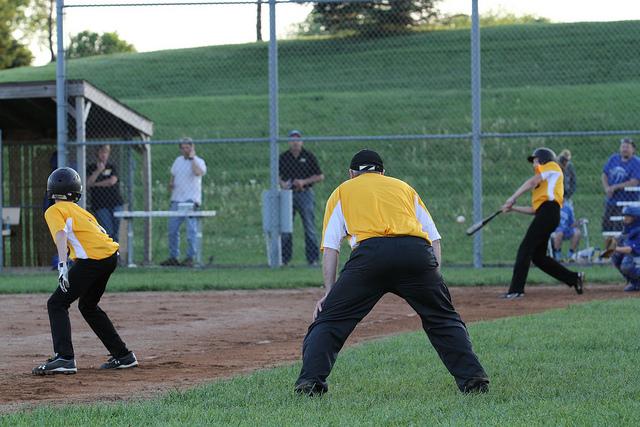What color is the team's shirt?
Be succinct. Yellow. Is there a player on third base?
Concise answer only. Yes. What is the man in the white shirt doing?
Give a very brief answer. Watching. 